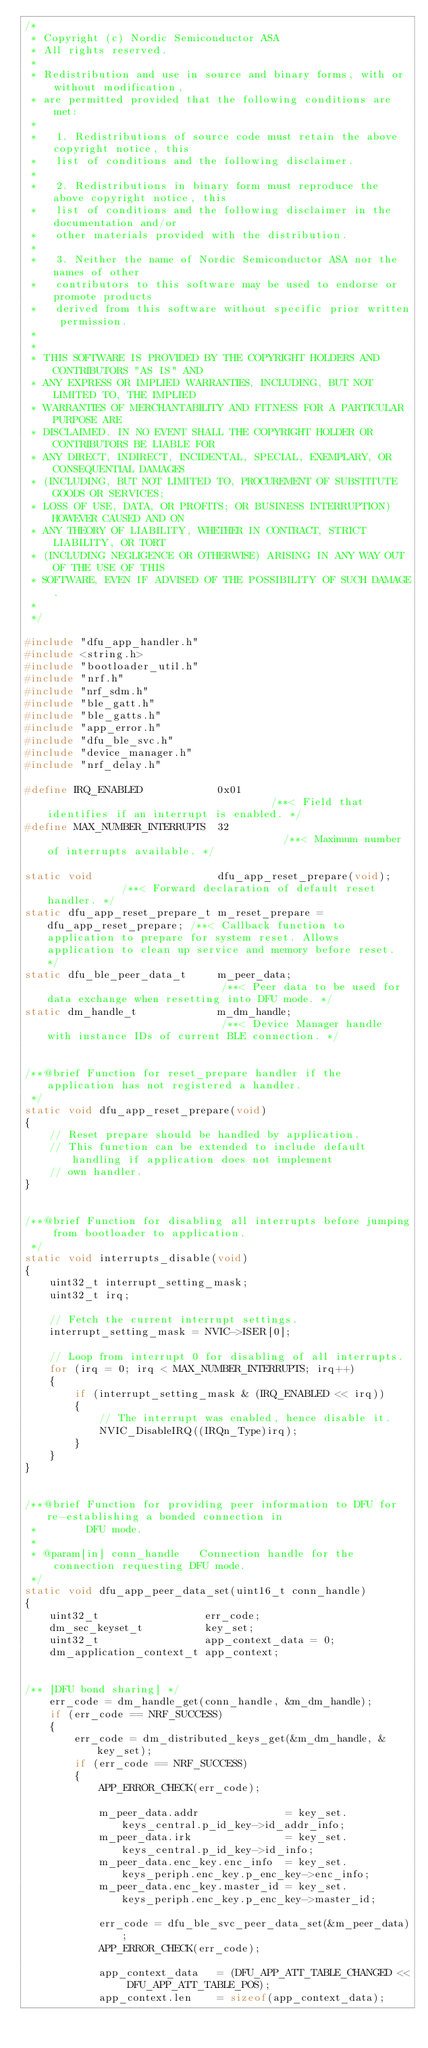Convert code to text. <code><loc_0><loc_0><loc_500><loc_500><_C_>/*
 * Copyright (c) Nordic Semiconductor ASA
 * All rights reserved.
 *
 * Redistribution and use in source and binary forms, with or without modification,
 * are permitted provided that the following conditions are met:
 *
 *   1. Redistributions of source code must retain the above copyright notice, this
 *   list of conditions and the following disclaimer.
 *
 *   2. Redistributions in binary form must reproduce the above copyright notice, this
 *   list of conditions and the following disclaimer in the documentation and/or
 *   other materials provided with the distribution.
 *
 *   3. Neither the name of Nordic Semiconductor ASA nor the names of other
 *   contributors to this software may be used to endorse or promote products
 *   derived from this software without specific prior written permission.
 *
 *
 * THIS SOFTWARE IS PROVIDED BY THE COPYRIGHT HOLDERS AND CONTRIBUTORS "AS IS" AND
 * ANY EXPRESS OR IMPLIED WARRANTIES, INCLUDING, BUT NOT LIMITED TO, THE IMPLIED
 * WARRANTIES OF MERCHANTABILITY AND FITNESS FOR A PARTICULAR PURPOSE ARE
 * DISCLAIMED. IN NO EVENT SHALL THE COPYRIGHT HOLDER OR CONTRIBUTORS BE LIABLE FOR
 * ANY DIRECT, INDIRECT, INCIDENTAL, SPECIAL, EXEMPLARY, OR CONSEQUENTIAL DAMAGES
 * (INCLUDING, BUT NOT LIMITED TO, PROCUREMENT OF SUBSTITUTE GOODS OR SERVICES;
 * LOSS OF USE, DATA, OR PROFITS; OR BUSINESS INTERRUPTION) HOWEVER CAUSED AND ON
 * ANY THEORY OF LIABILITY, WHETHER IN CONTRACT, STRICT LIABILITY, OR TORT
 * (INCLUDING NEGLIGENCE OR OTHERWISE) ARISING IN ANY WAY OUT OF THE USE OF THIS
 * SOFTWARE, EVEN IF ADVISED OF THE POSSIBILITY OF SUCH DAMAGE.
 *
 */

#include "dfu_app_handler.h"
#include <string.h>
#include "bootloader_util.h"
#include "nrf.h"
#include "nrf_sdm.h"
#include "ble_gatt.h"
#include "ble_gatts.h"
#include "app_error.h"
#include "dfu_ble_svc.h"
#include "device_manager.h"
#include "nrf_delay.h"

#define IRQ_ENABLED            0x01                                     /**< Field that identifies if an interrupt is enabled. */
#define MAX_NUMBER_INTERRUPTS  32                                       /**< Maximum number of interrupts available. */

static void                    dfu_app_reset_prepare(void);             /**< Forward declaration of default reset handler. */
static dfu_app_reset_prepare_t m_reset_prepare = dfu_app_reset_prepare; /**< Callback function to application to prepare for system reset. Allows application to clean up service and memory before reset. */
static dfu_ble_peer_data_t     m_peer_data;                             /**< Peer data to be used for data exchange when resetting into DFU mode. */
static dm_handle_t             m_dm_handle;                             /**< Device Manager handle with instance IDs of current BLE connection. */


/**@brief Function for reset_prepare handler if the application has not registered a handler.
 */
static void dfu_app_reset_prepare(void)
{
    // Reset prepare should be handled by application.
    // This function can be extended to include default handling if application does not implement
    // own handler.
}


/**@brief Function for disabling all interrupts before jumping from bootloader to application.
 */
static void interrupts_disable(void)
{
    uint32_t interrupt_setting_mask;
    uint32_t irq;

    // Fetch the current interrupt settings.
    interrupt_setting_mask = NVIC->ISER[0];

    // Loop from interrupt 0 for disabling of all interrupts.
    for (irq = 0; irq < MAX_NUMBER_INTERRUPTS; irq++)
    {
        if (interrupt_setting_mask & (IRQ_ENABLED << irq))
        {
            // The interrupt was enabled, hence disable it.
            NVIC_DisableIRQ((IRQn_Type)irq);
        }
    }
}


/**@brief Function for providing peer information to DFU for re-establishing a bonded connection in
 *        DFU mode.
 *
 * @param[in] conn_handle   Connection handle for the connection requesting DFU mode.
 */
static void dfu_app_peer_data_set(uint16_t conn_handle)
{
    uint32_t                 err_code;
    dm_sec_keyset_t          key_set;
    uint32_t                 app_context_data = 0;
    dm_application_context_t app_context;


/** [DFU bond sharing] */
    err_code = dm_handle_get(conn_handle, &m_dm_handle);
    if (err_code == NRF_SUCCESS)
    {
        err_code = dm_distributed_keys_get(&m_dm_handle, &key_set);
        if (err_code == NRF_SUCCESS)
        {
            APP_ERROR_CHECK(err_code);

            m_peer_data.addr              = key_set.keys_central.p_id_key->id_addr_info;
            m_peer_data.irk               = key_set.keys_central.p_id_key->id_info;
            m_peer_data.enc_key.enc_info  = key_set.keys_periph.enc_key.p_enc_key->enc_info;
            m_peer_data.enc_key.master_id = key_set.keys_periph.enc_key.p_enc_key->master_id;

            err_code = dfu_ble_svc_peer_data_set(&m_peer_data);
            APP_ERROR_CHECK(err_code);

            app_context_data   = (DFU_APP_ATT_TABLE_CHANGED << DFU_APP_ATT_TABLE_POS);
            app_context.len    = sizeof(app_context_data);</code> 